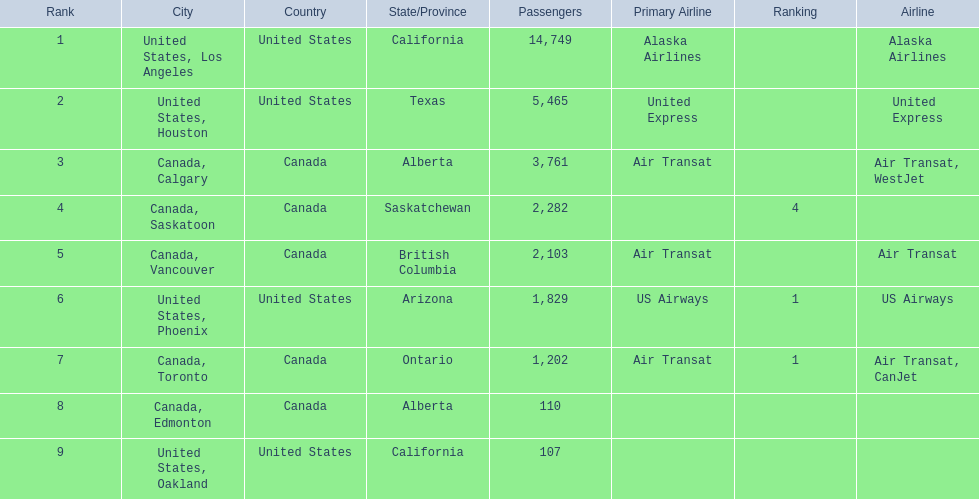What are the cities flown to? United States, Los Angeles, United States, Houston, Canada, Calgary, Canada, Saskatoon, Canada, Vancouver, United States, Phoenix, Canada, Toronto, Canada, Edmonton, United States, Oakland. What number of passengers did pheonix have? 1,829. 